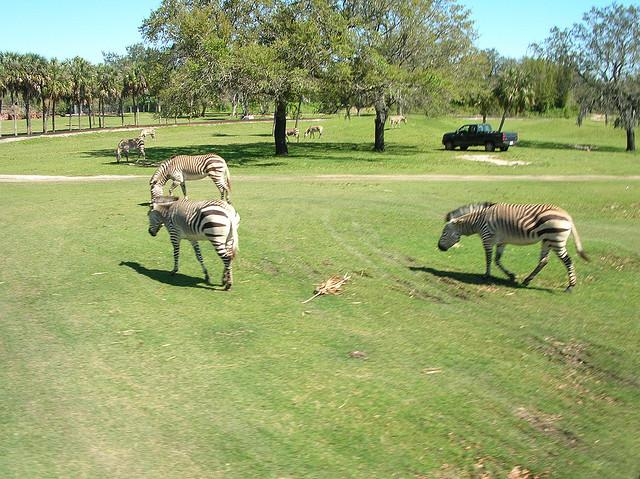What do the animals have? Please explain your reasoning. stripes. The animals are zebras. 